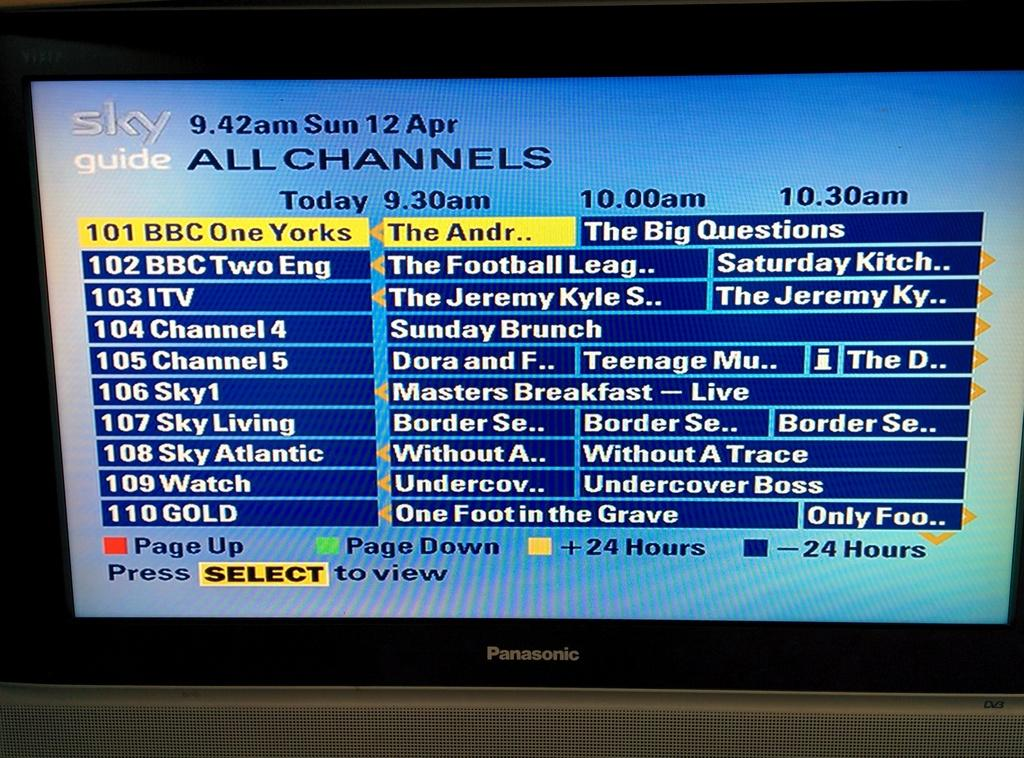Provide a one-sentence caption for the provided image. The TV Guide menu currently has channel 101 selected. 